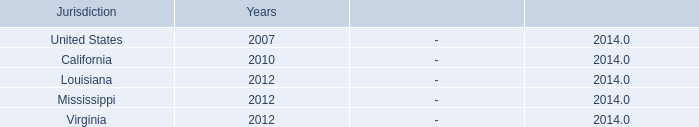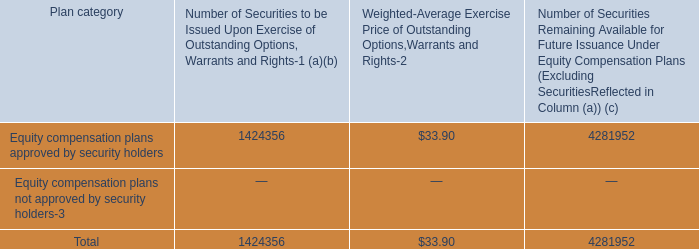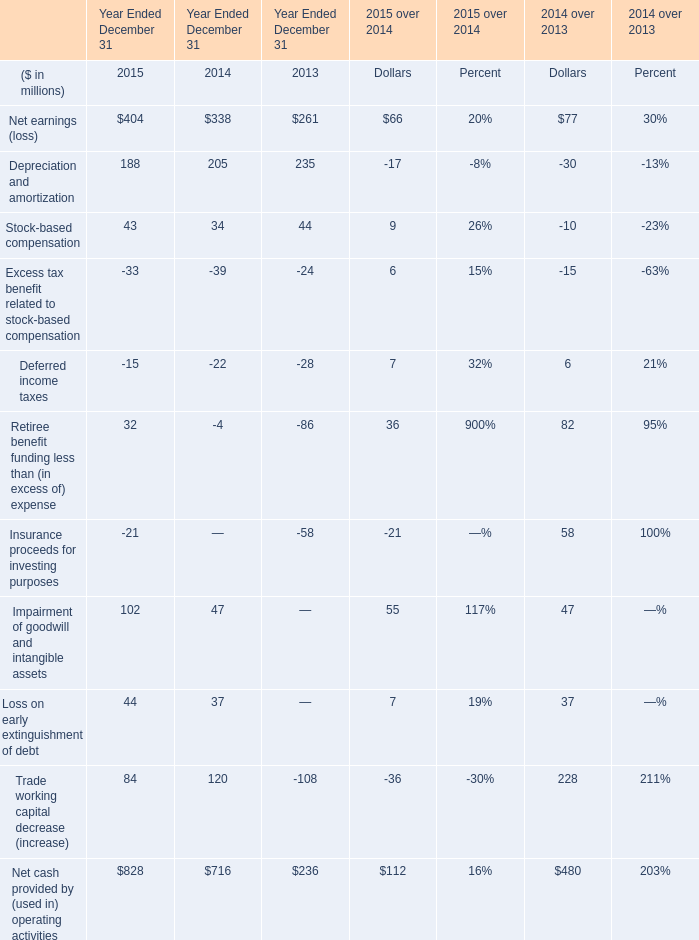What's the current growth rate of Excess tax benefit related to stock-based compensation? 
Computations: ((-33 - -39) / -39)
Answer: -0.15385. 